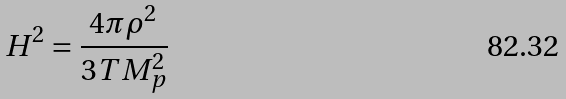Convert formula to latex. <formula><loc_0><loc_0><loc_500><loc_500>H ^ { 2 } = \frac { 4 \pi \rho ^ { 2 } } { 3 T M _ { p } ^ { 2 } }</formula> 